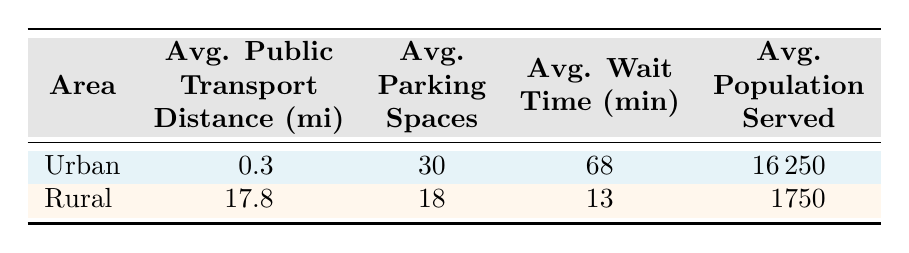What's the average public transport distance in urban areas? The table shows the average public transport distance for urban areas as 0.3 miles.
Answer: 0.3 miles What is the total average population served in rural areas? The table lists the average population served in rural areas as 1750.
Answer: 1750 Is the polling station in rural areas generally wheelchair accessible? The table lists only one of the rural polling stations as non-wheelchair accessible, while the average shows wheelchair accessibility to be true for rural areas.
Answer: No Which area has a greater average wait time, urban or rural? The average wait time for urban areas is 68 minutes, while for rural areas, it's 13 minutes. Rural areas have a shorter wait time than urban.
Answer: Urban What is the difference in average parking spaces between urban and rural areas? The average parking spaces in urban areas is 30, while in rural areas it is 18. The difference is 30 - 18 = 12 spaces.
Answer: 12 spaces What is the average public transport distance across both areas? The average public transport distance for urban areas is 0.3 miles and for rural areas is 17.8 miles. The average across both would be (0.3 + 17.8) / 2 = 9.05 miles.
Answer: 9.05 miles How many more voting machines are available on average in urban areas compared to rural areas? The average number of voting machines in urban areas is 18, while in rural areas it is 2. The difference is 18 - 2 = 16 machines.
Answer: 16 machines Is the average wait time longer in urban or rural areas? The average wait time in urban areas is 68 minutes, and in rural areas, it is 13 minutes, so urban areas have a longer average wait time.
Answer: Yes What area has higher average public transport distance? The average public transport distance for urban areas is 0.3 miles, while for rural areas it is 17.8 miles, so rural areas have higher average transport distance.
Answer: Rural 